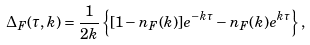<formula> <loc_0><loc_0><loc_500><loc_500>\Delta _ { F } ( \tau , k ) = \frac { 1 } { 2 k } \left \{ [ 1 - n _ { F } ( k ) ] e ^ { - k \tau } - n _ { F } ( k ) e ^ { k \tau } \right \} ,</formula> 